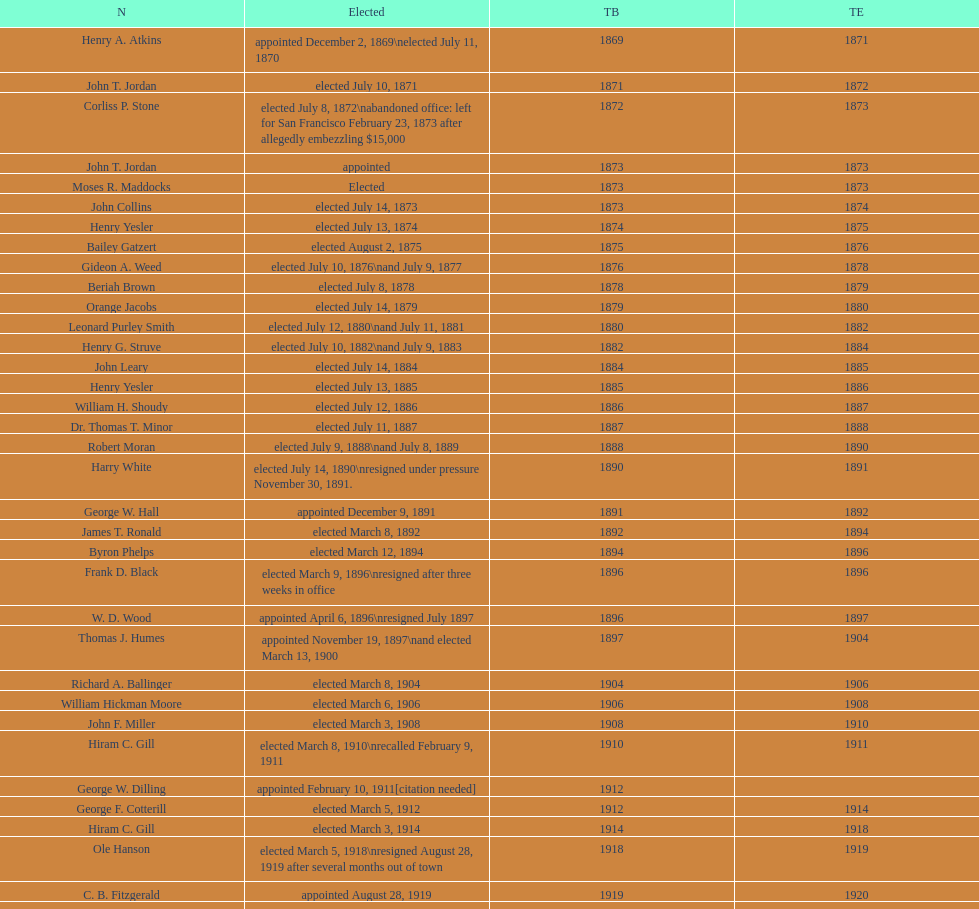Who began their term in 1890? Harry White. I'm looking to parse the entire table for insights. Could you assist me with that? {'header': ['N', 'Elected', 'TB', 'TE'], 'rows': [['Henry A. Atkins', 'appointed December 2, 1869\\nelected July 11, 1870', '1869', '1871'], ['John T. Jordan', 'elected July 10, 1871', '1871', '1872'], ['Corliss P. Stone', 'elected July 8, 1872\\nabandoned office: left for San Francisco February 23, 1873 after allegedly embezzling $15,000', '1872', '1873'], ['John T. Jordan', 'appointed', '1873', '1873'], ['Moses R. Maddocks', 'Elected', '1873', '1873'], ['John Collins', 'elected July 14, 1873', '1873', '1874'], ['Henry Yesler', 'elected July 13, 1874', '1874', '1875'], ['Bailey Gatzert', 'elected August 2, 1875', '1875', '1876'], ['Gideon A. Weed', 'elected July 10, 1876\\nand July 9, 1877', '1876', '1878'], ['Beriah Brown', 'elected July 8, 1878', '1878', '1879'], ['Orange Jacobs', 'elected July 14, 1879', '1879', '1880'], ['Leonard Purley Smith', 'elected July 12, 1880\\nand July 11, 1881', '1880', '1882'], ['Henry G. Struve', 'elected July 10, 1882\\nand July 9, 1883', '1882', '1884'], ['John Leary', 'elected July 14, 1884', '1884', '1885'], ['Henry Yesler', 'elected July 13, 1885', '1885', '1886'], ['William H. Shoudy', 'elected July 12, 1886', '1886', '1887'], ['Dr. Thomas T. Minor', 'elected July 11, 1887', '1887', '1888'], ['Robert Moran', 'elected July 9, 1888\\nand July 8, 1889', '1888', '1890'], ['Harry White', 'elected July 14, 1890\\nresigned under pressure November 30, 1891.', '1890', '1891'], ['George W. Hall', 'appointed December 9, 1891', '1891', '1892'], ['James T. Ronald', 'elected March 8, 1892', '1892', '1894'], ['Byron Phelps', 'elected March 12, 1894', '1894', '1896'], ['Frank D. Black', 'elected March 9, 1896\\nresigned after three weeks in office', '1896', '1896'], ['W. D. Wood', 'appointed April 6, 1896\\nresigned July 1897', '1896', '1897'], ['Thomas J. Humes', 'appointed November 19, 1897\\nand elected March 13, 1900', '1897', '1904'], ['Richard A. Ballinger', 'elected March 8, 1904', '1904', '1906'], ['William Hickman Moore', 'elected March 6, 1906', '1906', '1908'], ['John F. Miller', 'elected March 3, 1908', '1908', '1910'], ['Hiram C. Gill', 'elected March 8, 1910\\nrecalled February 9, 1911', '1910', '1911'], ['George W. Dilling', 'appointed February 10, 1911[citation needed]', '1912', ''], ['George F. Cotterill', 'elected March 5, 1912', '1912', '1914'], ['Hiram C. Gill', 'elected March 3, 1914', '1914', '1918'], ['Ole Hanson', 'elected March 5, 1918\\nresigned August 28, 1919 after several months out of town', '1918', '1919'], ['C. B. Fitzgerald', 'appointed August 28, 1919', '1919', '1920'], ['Hugh M. Caldwell', 'elected March 2, 1920', '1920', '1922'], ['Edwin J. Brown', 'elected May 2, 1922\\nand March 4, 1924', '1922', '1926'], ['Bertha Knight Landes', 'elected March 9, 1926', '1926', '1928'], ['Frank E. Edwards', 'elected March 6, 1928\\nand March 4, 1930\\nrecalled July 13, 1931', '1928', '1931'], ['Robert H. Harlin', 'appointed July 14, 1931', '1931', '1932'], ['John F. Dore', 'elected March 8, 1932', '1932', '1934'], ['Charles L. Smith', 'elected March 6, 1934', '1934', '1936'], ['John F. Dore', 'elected March 3, 1936\\nbecame gravely ill and was relieved of office April 13, 1938, already a lame duck after the 1938 election. He died five days later.', '1936', '1938'], ['Arthur B. Langlie', "elected March 8, 1938\\nappointed to take office early, April 27, 1938, after Dore's death.\\nelected March 5, 1940\\nresigned January 11, 1941, to become Governor of Washington", '1938', '1941'], ['John E. Carroll', 'appointed January 27, 1941', '1941', '1941'], ['Earl Millikin', 'elected March 4, 1941', '1941', '1942'], ['William F. Devin', 'elected March 3, 1942, March 7, 1944, March 5, 1946, and March 2, 1948', '1942', '1952'], ['Allan Pomeroy', 'elected March 4, 1952', '1952', '1956'], ['Gordon S. Clinton', 'elected March 6, 1956\\nand March 8, 1960', '1956', '1964'], ["James d'Orma Braman", 'elected March 10, 1964\\nresigned March 23, 1969, to accept an appointment as an Assistant Secretary in the Department of Transportation in the Nixon administration.', '1964', '1969'], ['Floyd C. Miller', 'appointed March 23, 1969', '1969', '1969'], ['Wesley C. Uhlman', 'elected November 4, 1969\\nand November 6, 1973\\nsurvived recall attempt on July 1, 1975', 'December 1, 1969', 'January 1, 1978'], ['Charles Royer', 'elected November 8, 1977, November 3, 1981, and November 5, 1985', 'January 1, 1978', 'January 1, 1990'], ['Norman B. Rice', 'elected November 7, 1989', 'January 1, 1990', 'January 1, 1998'], ['Paul Schell', 'elected November 4, 1997', 'January 1, 1998', 'January 1, 2002'], ['Gregory J. Nickels', 'elected November 6, 2001\\nand November 8, 2005', 'January 1, 2002', 'January 1, 2010'], ['Michael McGinn', 'elected November 3, 2009', 'January 1, 2010', 'January 1, 2014'], ['Ed Murray', 'elected November 5, 2013', 'January 1, 2014', 'present']]} 